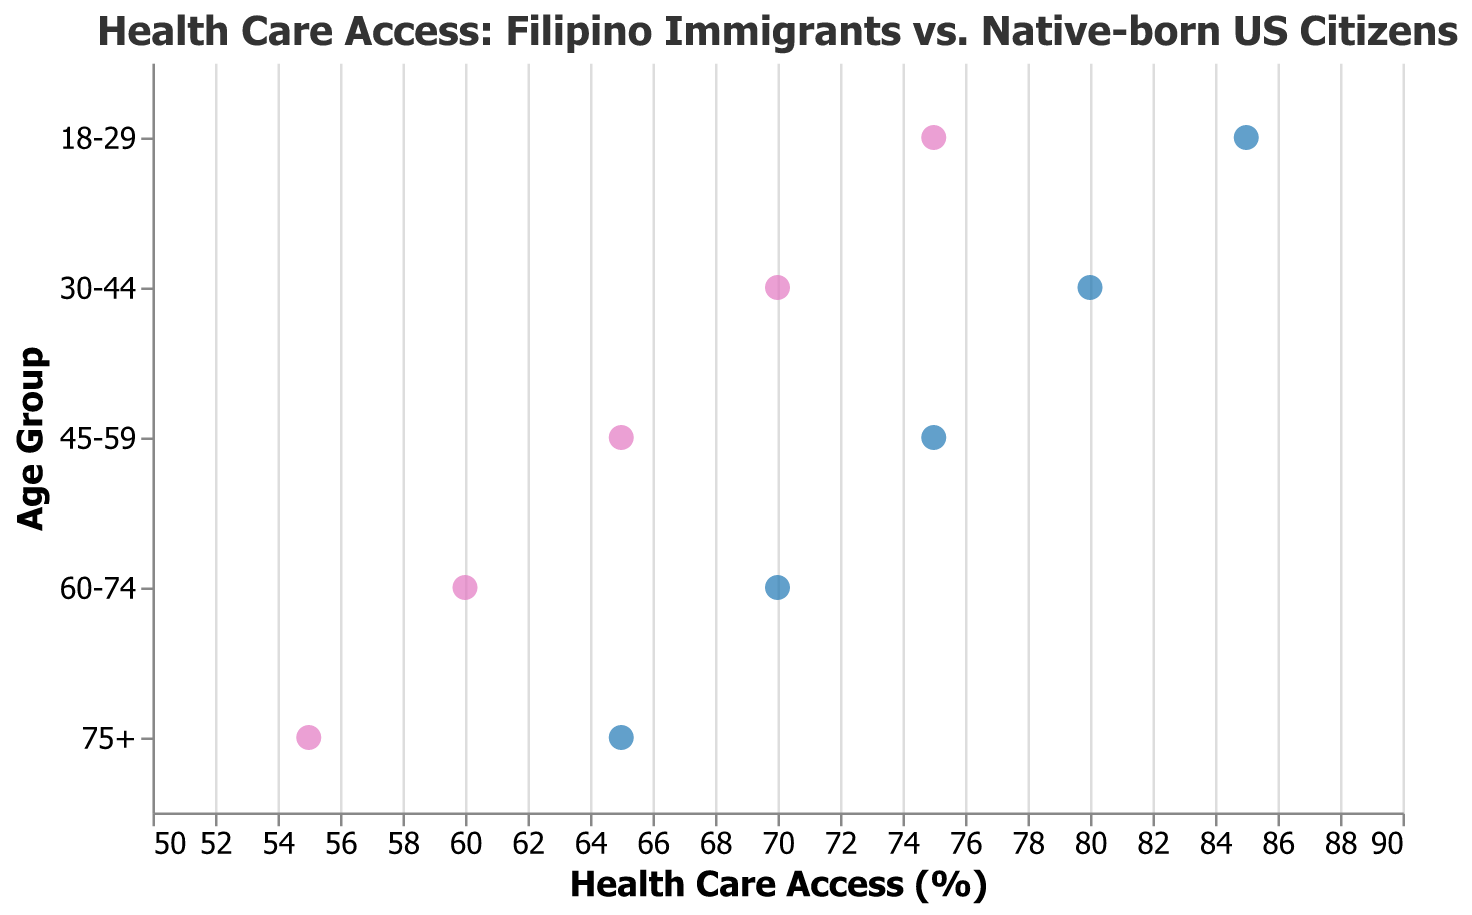What is the title of the plot? The title of the plot is displayed at the top and provides the context of what the visual representation is about. The title is "Health Care Access: Filipino Immigrants vs. Native-born US Citizens."
Answer: Health Care Access: Filipino Immigrants vs. Native-born US Citizens What are the age groups represented in the plot? The age groups are shown on the y-axis, and they are: 18-29, 30-44, 45-59, 60-74, and 75+.
Answer: 18-29, 30-44, 45-59, 60-74, 75+ Which age group shows the biggest gap in health care access between Filipino immigrants and Native-born US citizens? By visual inspection, compare the lengths of the lines (the gaps between the pink and blue dots) for each age group. The longest line indicates the largest gap. The age group 18-29 has the largest gap.
Answer: 18-29 What is the health care access percentage for Filipino immigrants aged 45-59? Locate the point corresponding to Filipino immigrants in the 45-59 age group. It's 65%.
Answer: 65% How does the health care access for Native-born US citizens aged 75+ compare to that of Filipino immigrants in the same age group? For the age group 75+, compare the health care access percentages for Native-born US citizens and Filipino immigrants. Native-born US citizens have 65% while Filipino immigrants have 55%.
Answer: Native-born US citizens have 10% higher access What is the average health care access percentage for Filipino immigrants across all age groups? Sum the percentages for Filipino immigrants across all age groups (75 + 70 + 65 + 60 + 55) and divide by the number of age groups (5). The calculation is (75 + 70 + 65 + 60 + 55) / 5.
Answer: 65% Which age group has the closest health care access percentages between the two populations? Identify the age group where the pink and blue dots are closest to each other. The age group 60-74 shows the smallest gap between the two populations, both having access within a 10% difference.
Answer: 60-74 Which population shows a more consistent decline in health care access as age increases? Examine the trend lines for both Filipino immigrants and Native-born US citizens. Both populations show a decline, but the slope (decline rate) is steeper and more consistent for Filipino immigrants.
Answer: Filipino immigrants What is the difference in health care access between Filipino immigrants and Native-born US citizens in the 30-44 age group? Subtract the health care access percentage of Filipino immigrants (70%) from that of Native-born US citizens (80%) in the 30-44 age group. The difference is 80% - 70%.
Answer: 10% Which age group of Native-born US citizens has the highest health care access percentage? Look at the blue dots (Native-born US citizens) and identify the highest percentage. The highest health care access percentage for Native-born US citizens is in the 18-29 age group with 85%.
Answer: 18-29 